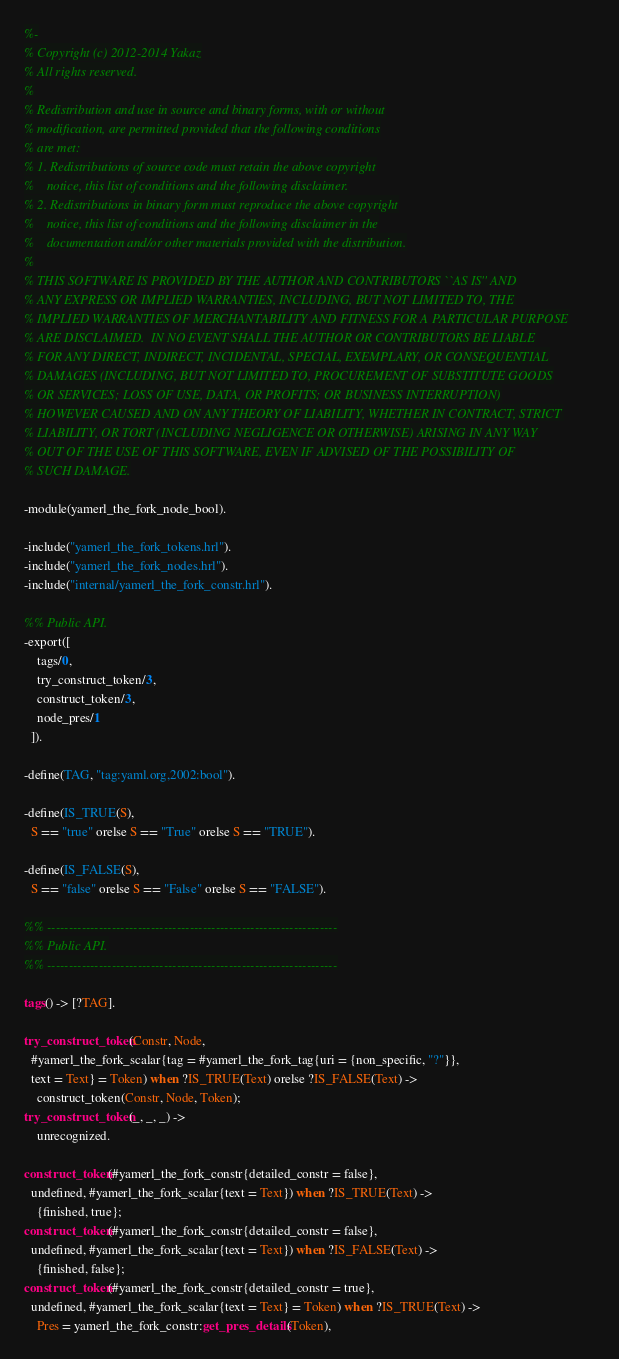Convert code to text. <code><loc_0><loc_0><loc_500><loc_500><_Erlang_>%-
% Copyright (c) 2012-2014 Yakaz
% All rights reserved.
%
% Redistribution and use in source and binary forms, with or without
% modification, are permitted provided that the following conditions
% are met:
% 1. Redistributions of source code must retain the above copyright
%    notice, this list of conditions and the following disclaimer.
% 2. Redistributions in binary form must reproduce the above copyright
%    notice, this list of conditions and the following disclaimer in the
%    documentation and/or other materials provided with the distribution.
%
% THIS SOFTWARE IS PROVIDED BY THE AUTHOR AND CONTRIBUTORS ``AS IS'' AND
% ANY EXPRESS OR IMPLIED WARRANTIES, INCLUDING, BUT NOT LIMITED TO, THE
% IMPLIED WARRANTIES OF MERCHANTABILITY AND FITNESS FOR A PARTICULAR PURPOSE
% ARE DISCLAIMED.  IN NO EVENT SHALL THE AUTHOR OR CONTRIBUTORS BE LIABLE
% FOR ANY DIRECT, INDIRECT, INCIDENTAL, SPECIAL, EXEMPLARY, OR CONSEQUENTIAL
% DAMAGES (INCLUDING, BUT NOT LIMITED TO, PROCUREMENT OF SUBSTITUTE GOODS
% OR SERVICES; LOSS OF USE, DATA, OR PROFITS; OR BUSINESS INTERRUPTION)
% HOWEVER CAUSED AND ON ANY THEORY OF LIABILITY, WHETHER IN CONTRACT, STRICT
% LIABILITY, OR TORT (INCLUDING NEGLIGENCE OR OTHERWISE) ARISING IN ANY WAY
% OUT OF THE USE OF THIS SOFTWARE, EVEN IF ADVISED OF THE POSSIBILITY OF
% SUCH DAMAGE.

-module(yamerl_the_fork_node_bool).

-include("yamerl_the_fork_tokens.hrl").
-include("yamerl_the_fork_nodes.hrl").
-include("internal/yamerl_the_fork_constr.hrl").

%% Public API.
-export([
    tags/0,
    try_construct_token/3,
    construct_token/3,
    node_pres/1
  ]).

-define(TAG, "tag:yaml.org,2002:bool").

-define(IS_TRUE(S),
  S == "true" orelse S == "True" orelse S == "TRUE").

-define(IS_FALSE(S),
  S == "false" orelse S == "False" orelse S == "FALSE").

%% -------------------------------------------------------------------
%% Public API.
%% -------------------------------------------------------------------

tags() -> [?TAG].

try_construct_token(Constr, Node,
  #yamerl_the_fork_scalar{tag = #yamerl_the_fork_tag{uri = {non_specific, "?"}},
  text = Text} = Token) when ?IS_TRUE(Text) orelse ?IS_FALSE(Text) ->
    construct_token(Constr, Node, Token);
try_construct_token(_, _, _) ->
    unrecognized.

construct_token(#yamerl_the_fork_constr{detailed_constr = false},
  undefined, #yamerl_the_fork_scalar{text = Text}) when ?IS_TRUE(Text) ->
    {finished, true};
construct_token(#yamerl_the_fork_constr{detailed_constr = false},
  undefined, #yamerl_the_fork_scalar{text = Text}) when ?IS_FALSE(Text) ->
    {finished, false};
construct_token(#yamerl_the_fork_constr{detailed_constr = true},
  undefined, #yamerl_the_fork_scalar{text = Text} = Token) when ?IS_TRUE(Text) ->
    Pres = yamerl_the_fork_constr:get_pres_details(Token),</code> 